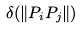Convert formula to latex. <formula><loc_0><loc_0><loc_500><loc_500>\delta ( \| P _ { i } P _ { j } \| )</formula> 